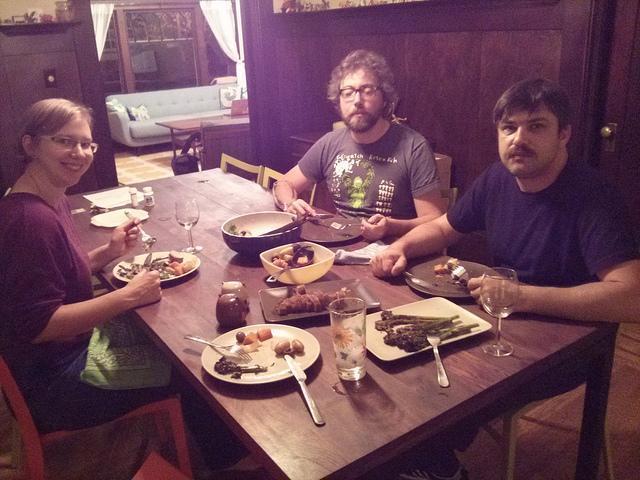How many people are pictured?
Give a very brief answer. 3. How many people can be seen?
Give a very brief answer. 3. How many bowls are in the photo?
Give a very brief answer. 1. How many cars are on the street?
Give a very brief answer. 0. 